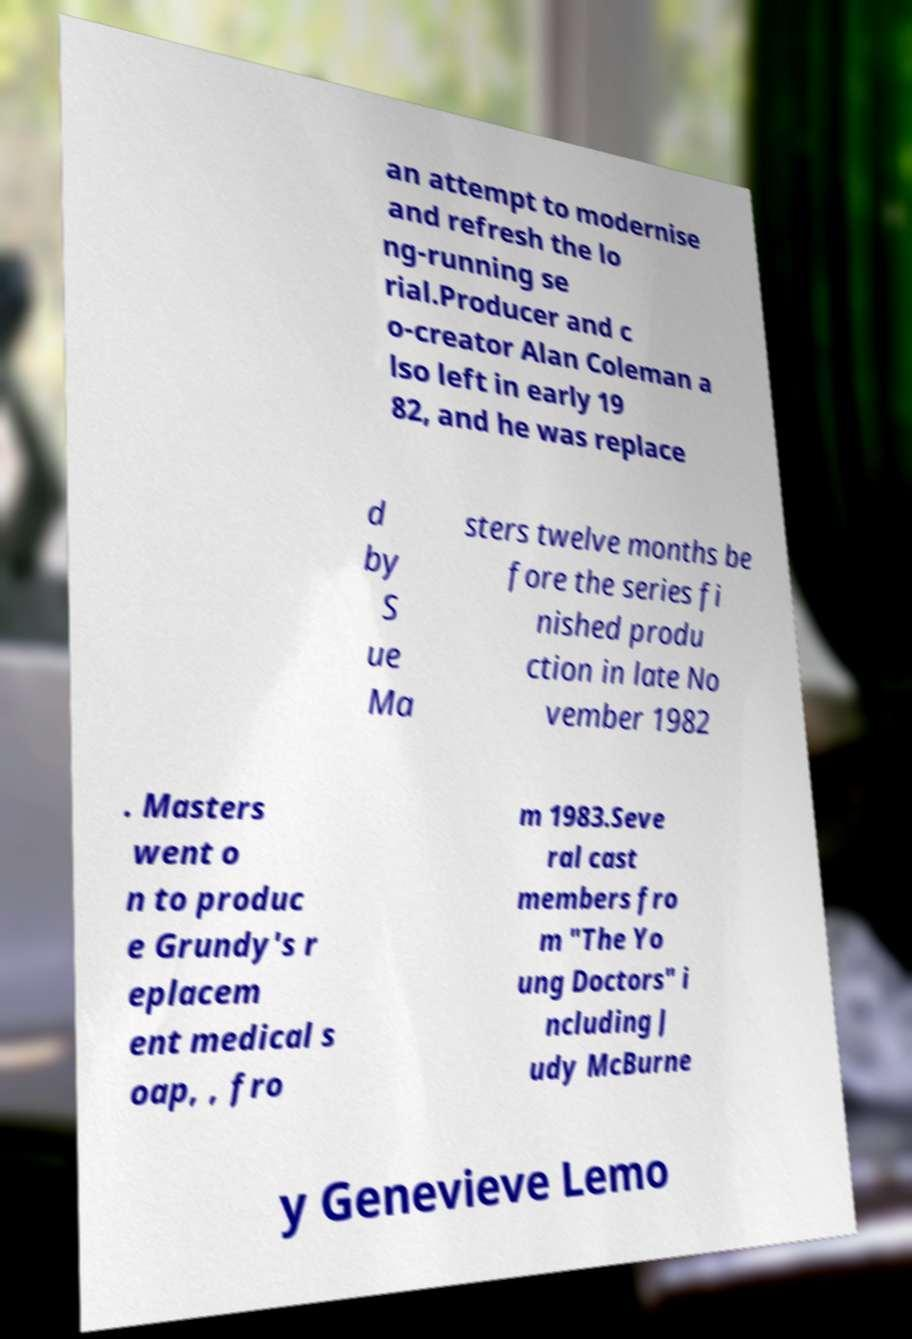Please read and relay the text visible in this image. What does it say? an attempt to modernise and refresh the lo ng-running se rial.Producer and c o-creator Alan Coleman a lso left in early 19 82, and he was replace d by S ue Ma sters twelve months be fore the series fi nished produ ction in late No vember 1982 . Masters went o n to produc e Grundy's r eplacem ent medical s oap, , fro m 1983.Seve ral cast members fro m "The Yo ung Doctors" i ncluding J udy McBurne y Genevieve Lemo 